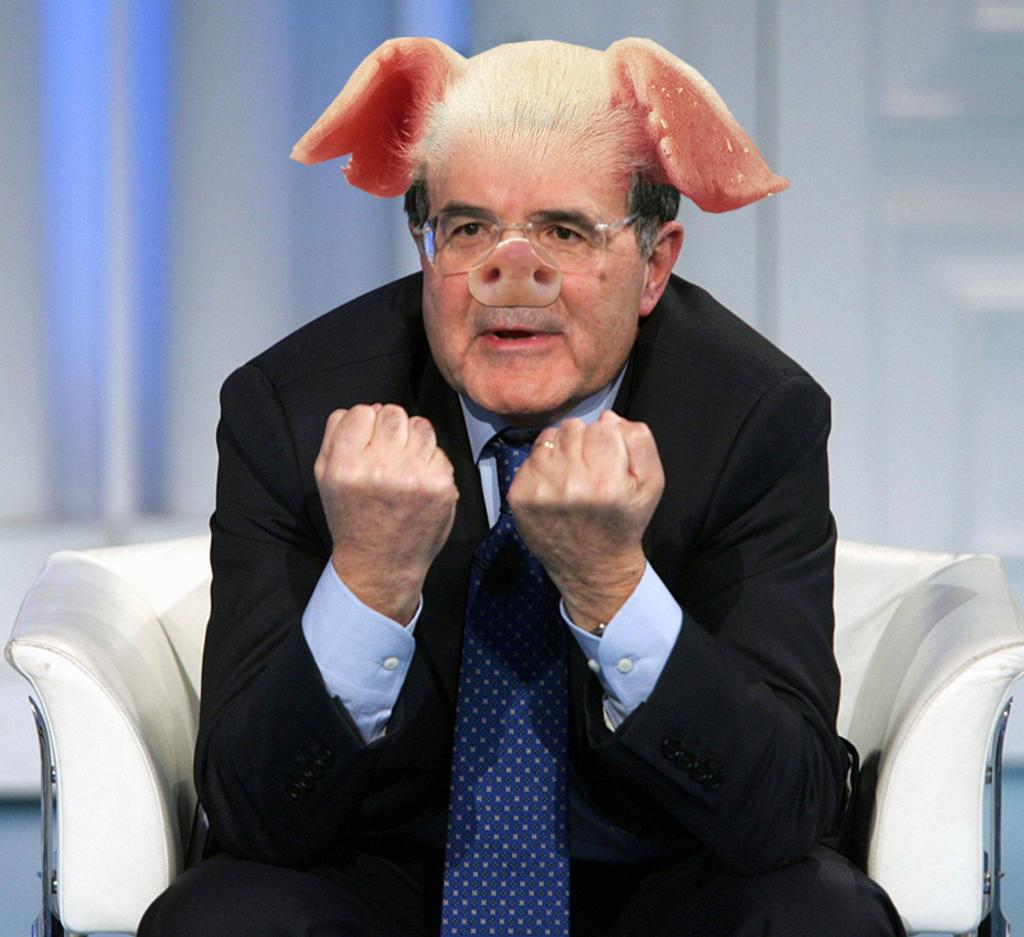Who is present in the image? There is a man in the image. What is the man doing in the image? The man is sitting on a couch. What is the man wearing on his face in the image? The man is wearing a mask with pig's nose and ears. What is the level of pollution in the room where the man is sitting? There is no information about the level of pollution in the image, as it only shows a man sitting on a couch with a mask on his face? 